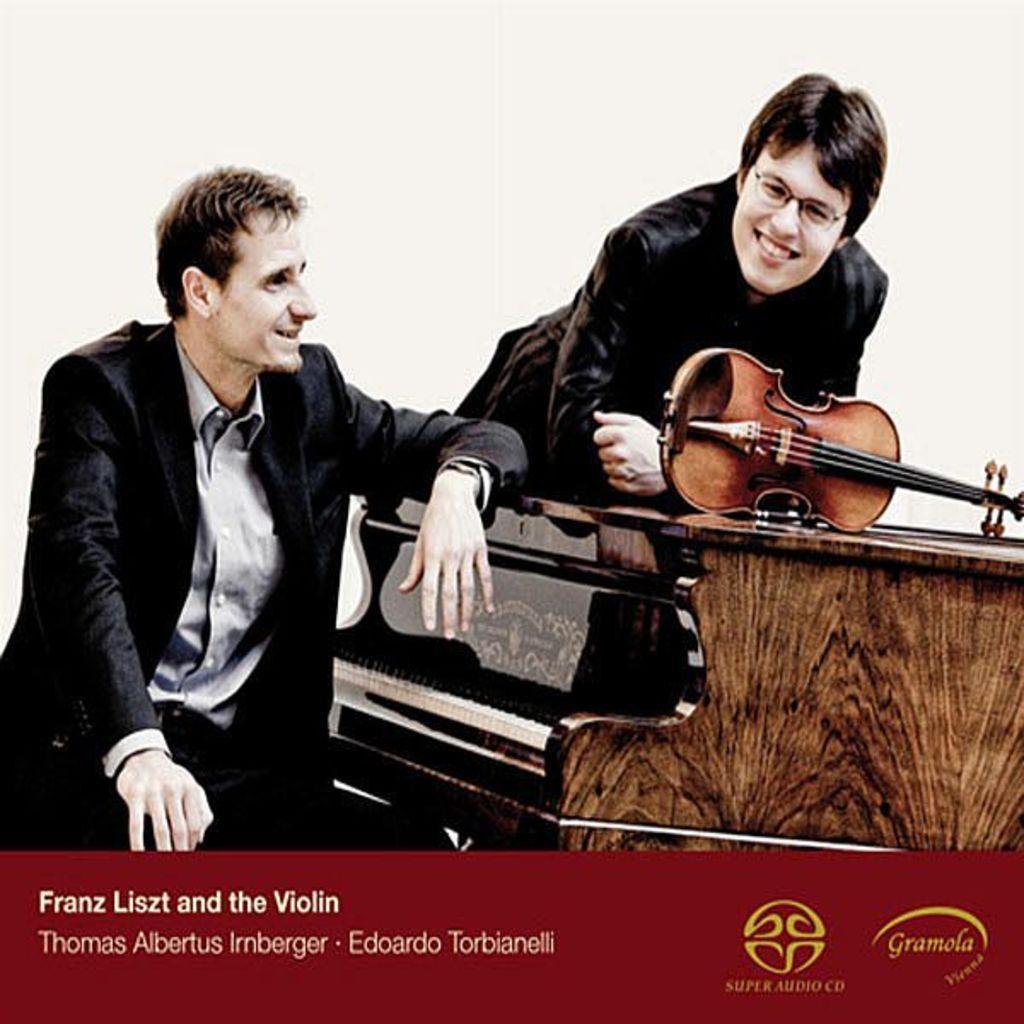Describe this image in one or two sentences. This image consists of a poster with a few images and a text on it. On the left side of the image a man is sitting on the chair. On the right side of the image there is a keyboard and there is a violin on the keyboard. A man is standing on the floor and he is with a smiling face. 